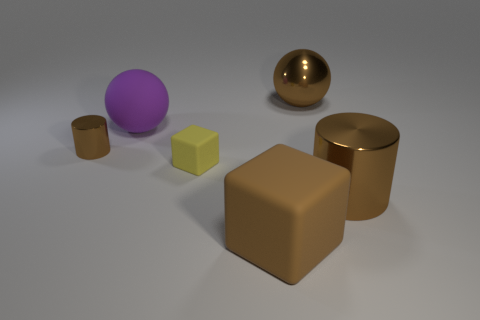How would you classify the materials of the objects shown? The objects in the image appear to have been rendered with varying textures and materials. The large brown block and the smaller one adjacent to it have a matte, rubber-like surface. In contrast, the sphere to the far left and the cylindrical object closest to the viewer exhibit reflective metallic surfaces. Meanwhile, the remaining purple sphere and yellow cube have more of a plastic look with a diffuse reflection, which differentiates them from the more metallic textures. 